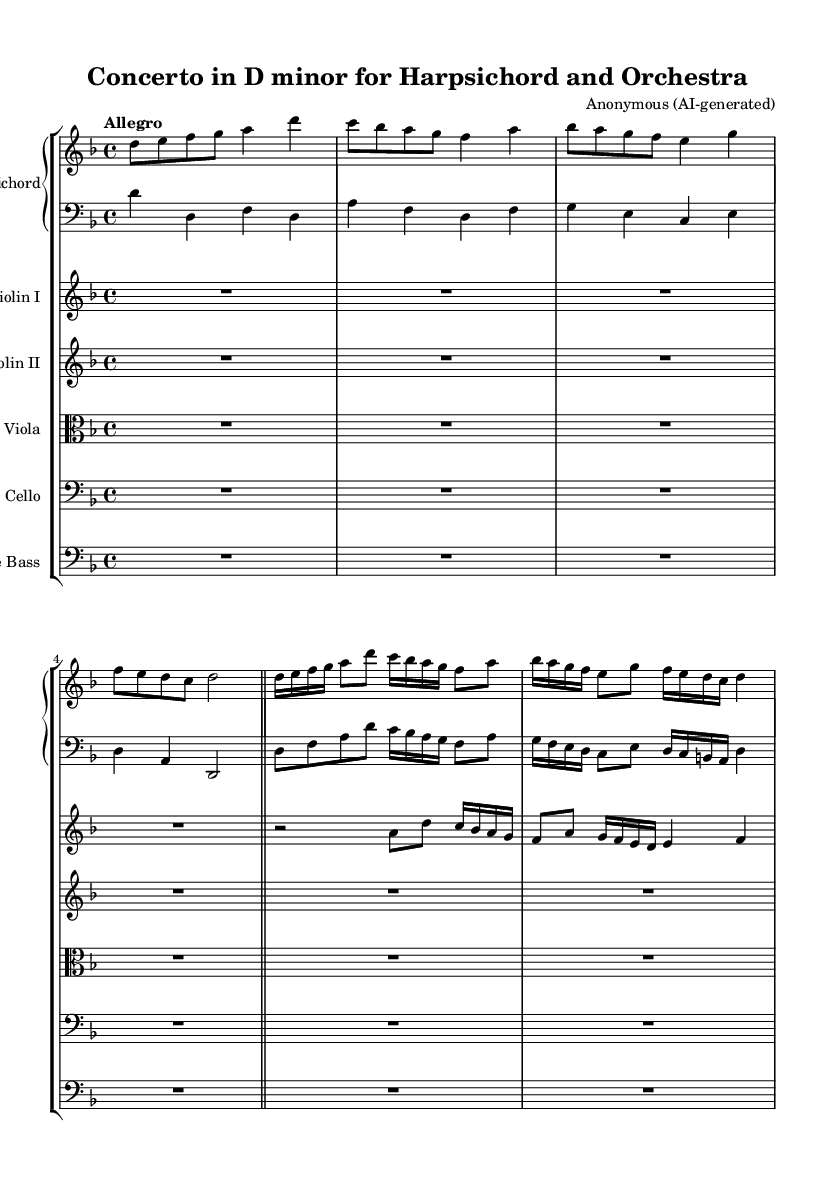What is the key signature of this music? The key signature is D minor, which has one flat (B flat). This is identified by looking at the beginning of the staff where the sharps and flats are indicated.
Answer: D minor What is the time signature of this music? The time signature is 4/4, which means there are four beats in a measure and the quarter note gets one beat. This is found at the beginning of the music, right after the key signature.
Answer: 4/4 What is the tempo marking for this piece? The tempo marking is Allegro, indicating a fast and lively pace. This is noted at the start of the score above the staff.
Answer: Allegro How many measures are in the first section of the harpsichord part? There are 8 measures in the first section of the harpsichord part, as counted from the beginning of the staff to the double bar line.
Answer: 8 What type of compositional technique is prominently used in this concerto? The predominant technique is counterpoint, where multiple melodic lines are intertwined, creating complex interactions. This is a hallmark of Baroque music, specifically seen in how different instruments play different but harmonically related lines.
Answer: Counterpoint What instruments comprise the ensemble for this piece? The ensemble includes a harpsichord for the solo line, violins I and II, viola, cello, and double bass for accompaniment, as listed in the staff group in the score.
Answer: Harpsichord, Violins I & II, Viola, Cello, Double Bass 